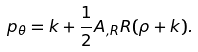Convert formula to latex. <formula><loc_0><loc_0><loc_500><loc_500>p _ { \theta } = k + \frac { 1 } { 2 } A _ { , R } R ( \rho + k ) .</formula> 